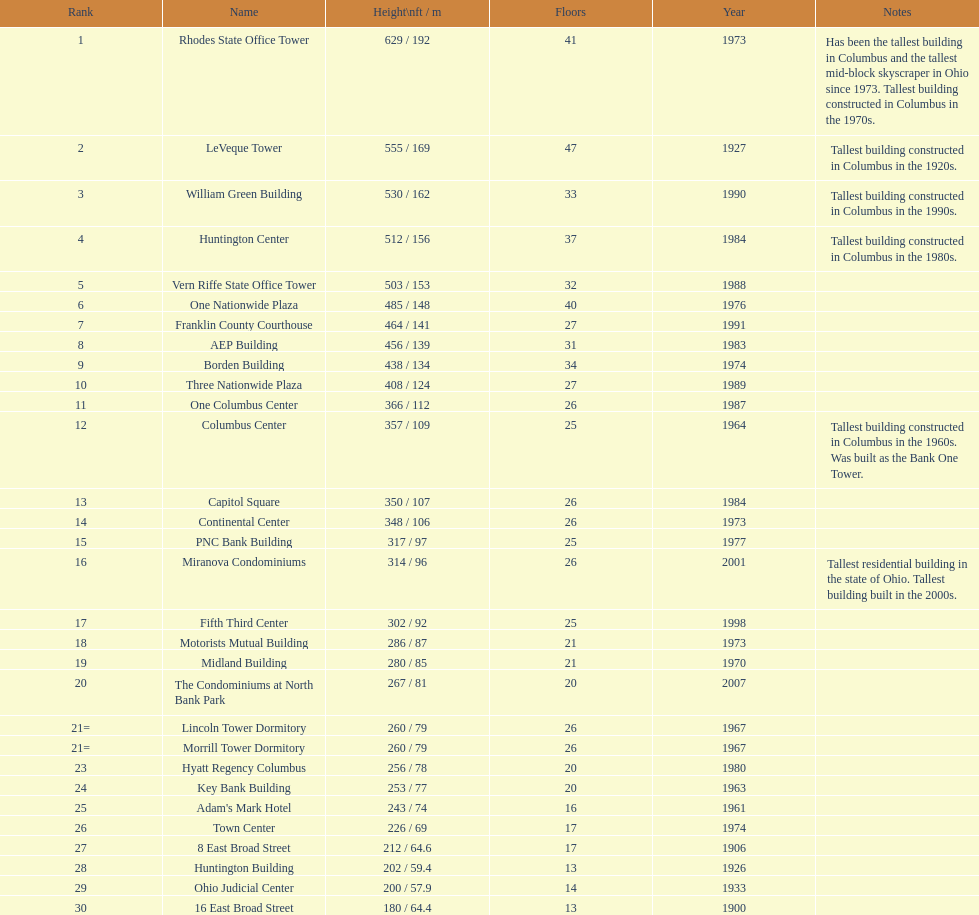Can you list the buildings that are over 500 feet tall? Rhodes State Office Tower, LeVeque Tower, William Green Building, Huntington Center, Vern Riffe State Office Tower. 